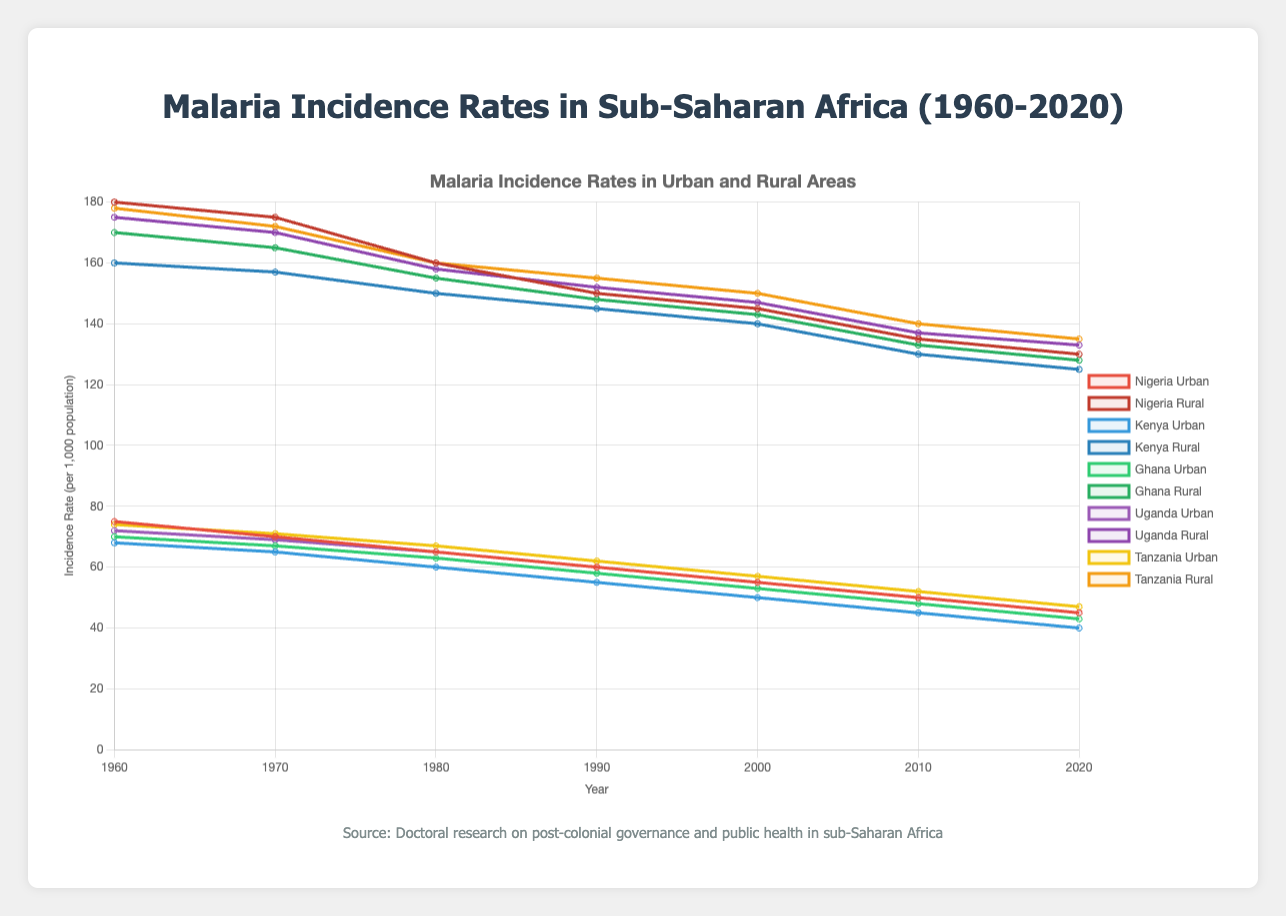How did the urban malaria incidence rate in Nigeria change from 1960 to 2020? In 1960, the urban incidence rate in Nigeria was 75 per 1,000 population. By 2020, it had decreased to 45 per 1,000 population. The change is 75 - 45 = 30.
Answer: The incidence rate decreased by 30 per 1,000 population What country had the highest rural malaria incidence rate in 2020, and what was the value? To find this, look for the highest value among the rural incidence rates in 2020. The rates are: Nigeria 130, Kenya 125, Ghana 128, Uganda 133, and Tanzania 135. Tanzania has the highest rate at 135.
Answer: Tanzania, 135 Compare the malaria incidence rate reduction in rural areas of Kenya and Uganda between 1960 and 2020. Kenya's rural rates decreased from 160 to 125, and Uganda's from 175 to 133. For Kenya: 160 - 125 = 35. For Uganda: 175 - 133 = 42. Uganda's reduction (42) is greater than Kenya's (35).
Answer: Uganda's reduction (42) is greater than Kenya's (35) What is the average malaria incidence rate in urban areas across all countries in 2010? Add the 2010 urban incidence rates for Nigeria (50), Kenya (45), Ghana (48), Uganda (50), and Tanzania (52) and divide by 5. (50 + 45 + 48 + 50 + 52) / 5 = 245 / 5 = 49.
Answer: 49 per 1,000 population Which country experienced the largest decrease in urban malaria incidence rates between 1960 and 2020? Calculate the decrease for each country. Nigeria: 75 - 45 = 30, Kenya: 68 - 40 = 28, Ghana: 70 - 43 = 27, Uganda: 72 - 45 = 27, Tanzania: 74 - 47 = 27. Largest decrease is in Nigeria with 30.
Answer: Nigeria, 30 How does the rural malaria incidence rate in Tanzania in 2020 compare to its urban rate in the same year? In 2020, Tanzania's rural rate was 135, and the urban rate was 47. The comparison: 135 (rural) is much higher than 47 (urban).
Answer: Rural rate is higher by 88 What was the combined malaria incidence rate for both urban and rural areas of Ghana in 1960? Ghana's 1960 urban rate is 70 and rural rate is 170. Combined rate: 70 + 170 = 240.
Answer: 240 per 1,000 population Which country had the smallest rural malaria incidence rate in 1970, and what was the value? Review the rural rates for 1970: Nigeria 175, Kenya 157, Ghana 165, Uganda 170, Tanzania 172. The smallest is Kenya at 157.
Answer: Kenya, 157 How did the urban malaria incidence rate in Uganda change every decade from 1960 to 2020? Starting from 1960: 72, 1960-1970: 69 (-3), 1970-1980: 65 (-4), 1980-1990: 60 (-5), 1990-2000: 55 (-5), 2000-2010: 50 (-5), 2010-2020: 45 (-5). Steps show a consistent decline every decade.
Answer: Decreased consistently over decades Compare the overall trend of malaria incidence rates in urban with rural areas across all countries from 1960 to 2020. Urban rates steadily decrease every decade, e.g., Nigeria (75 to 45), Kenya (68 to 40). Rural rates also decrease but remain higher, e.g., Nigeria (180 to 130), Kenya (160 to 125). Both trends show declines, urban rates are lower.
Answer: Both decreased, urban rates consistently lower 